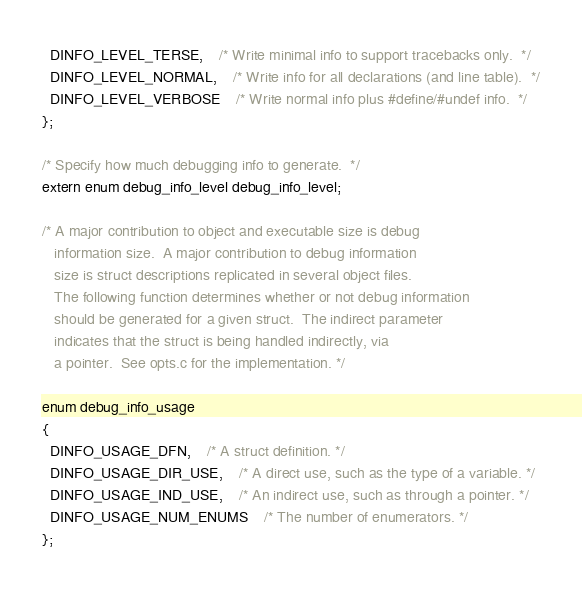<code> <loc_0><loc_0><loc_500><loc_500><_C_>  DINFO_LEVEL_TERSE,	/* Write minimal info to support tracebacks only.  */
  DINFO_LEVEL_NORMAL,	/* Write info for all declarations (and line table).  */
  DINFO_LEVEL_VERBOSE	/* Write normal info plus #define/#undef info.  */
};

/* Specify how much debugging info to generate.  */
extern enum debug_info_level debug_info_level;

/* A major contribution to object and executable size is debug
   information size.  A major contribution to debug information
   size is struct descriptions replicated in several object files.
   The following function determines whether or not debug information
   should be generated for a given struct.  The indirect parameter
   indicates that the struct is being handled indirectly, via
   a pointer.  See opts.c for the implementation. */

enum debug_info_usage
{
  DINFO_USAGE_DFN,	/* A struct definition. */
  DINFO_USAGE_DIR_USE,	/* A direct use, such as the type of a variable. */
  DINFO_USAGE_IND_USE,	/* An indirect use, such as through a pointer. */
  DINFO_USAGE_NUM_ENUMS	/* The number of enumerators. */
};
</code> 